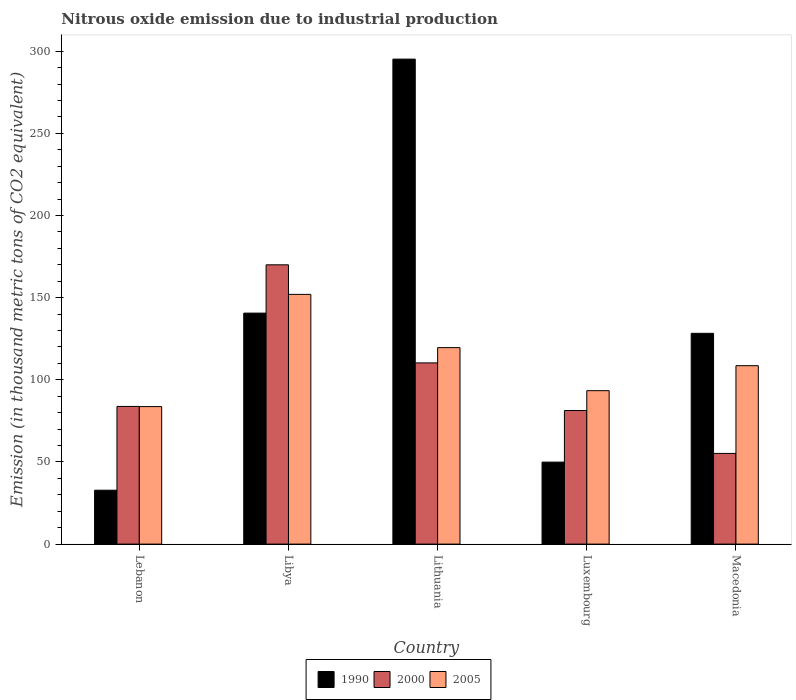How many different coloured bars are there?
Offer a very short reply. 3. Are the number of bars per tick equal to the number of legend labels?
Your answer should be compact. Yes. Are the number of bars on each tick of the X-axis equal?
Give a very brief answer. Yes. How many bars are there on the 4th tick from the left?
Your answer should be very brief. 3. What is the label of the 1st group of bars from the left?
Offer a terse response. Lebanon. In how many cases, is the number of bars for a given country not equal to the number of legend labels?
Make the answer very short. 0. What is the amount of nitrous oxide emitted in 2000 in Lithuania?
Give a very brief answer. 110.3. Across all countries, what is the maximum amount of nitrous oxide emitted in 2000?
Keep it short and to the point. 170. Across all countries, what is the minimum amount of nitrous oxide emitted in 1990?
Offer a terse response. 32.8. In which country was the amount of nitrous oxide emitted in 1990 maximum?
Keep it short and to the point. Lithuania. In which country was the amount of nitrous oxide emitted in 2005 minimum?
Offer a terse response. Lebanon. What is the total amount of nitrous oxide emitted in 2000 in the graph?
Provide a succinct answer. 500.6. What is the difference between the amount of nitrous oxide emitted in 1990 in Lithuania and that in Luxembourg?
Offer a terse response. 245.3. What is the difference between the amount of nitrous oxide emitted in 2000 in Lithuania and the amount of nitrous oxide emitted in 1990 in Luxembourg?
Your answer should be very brief. 60.4. What is the average amount of nitrous oxide emitted in 2000 per country?
Provide a succinct answer. 100.12. What is the difference between the amount of nitrous oxide emitted of/in 1990 and amount of nitrous oxide emitted of/in 2000 in Macedonia?
Your answer should be compact. 73.1. What is the ratio of the amount of nitrous oxide emitted in 2000 in Libya to that in Luxembourg?
Give a very brief answer. 2.09. Is the amount of nitrous oxide emitted in 2000 in Lebanon less than that in Luxembourg?
Provide a short and direct response. No. Is the difference between the amount of nitrous oxide emitted in 1990 in Lebanon and Lithuania greater than the difference between the amount of nitrous oxide emitted in 2000 in Lebanon and Lithuania?
Your answer should be very brief. No. What is the difference between the highest and the second highest amount of nitrous oxide emitted in 1990?
Your response must be concise. -12.3. What is the difference between the highest and the lowest amount of nitrous oxide emitted in 2000?
Your response must be concise. 114.8. In how many countries, is the amount of nitrous oxide emitted in 2000 greater than the average amount of nitrous oxide emitted in 2000 taken over all countries?
Your response must be concise. 2. Is the sum of the amount of nitrous oxide emitted in 1990 in Libya and Macedonia greater than the maximum amount of nitrous oxide emitted in 2000 across all countries?
Your response must be concise. Yes. What does the 2nd bar from the left in Libya represents?
Your response must be concise. 2000. How many bars are there?
Provide a short and direct response. 15. What is the difference between two consecutive major ticks on the Y-axis?
Make the answer very short. 50. Are the values on the major ticks of Y-axis written in scientific E-notation?
Offer a terse response. No. Does the graph contain any zero values?
Your answer should be very brief. No. How many legend labels are there?
Give a very brief answer. 3. What is the title of the graph?
Provide a short and direct response. Nitrous oxide emission due to industrial production. What is the label or title of the Y-axis?
Provide a succinct answer. Emission (in thousand metric tons of CO2 equivalent). What is the Emission (in thousand metric tons of CO2 equivalent) in 1990 in Lebanon?
Your answer should be very brief. 32.8. What is the Emission (in thousand metric tons of CO2 equivalent) of 2000 in Lebanon?
Make the answer very short. 83.8. What is the Emission (in thousand metric tons of CO2 equivalent) in 2005 in Lebanon?
Your answer should be very brief. 83.7. What is the Emission (in thousand metric tons of CO2 equivalent) of 1990 in Libya?
Provide a succinct answer. 140.6. What is the Emission (in thousand metric tons of CO2 equivalent) of 2000 in Libya?
Offer a very short reply. 170. What is the Emission (in thousand metric tons of CO2 equivalent) of 2005 in Libya?
Provide a short and direct response. 152. What is the Emission (in thousand metric tons of CO2 equivalent) in 1990 in Lithuania?
Make the answer very short. 295.2. What is the Emission (in thousand metric tons of CO2 equivalent) of 2000 in Lithuania?
Offer a very short reply. 110.3. What is the Emission (in thousand metric tons of CO2 equivalent) of 2005 in Lithuania?
Provide a succinct answer. 119.6. What is the Emission (in thousand metric tons of CO2 equivalent) in 1990 in Luxembourg?
Offer a terse response. 49.9. What is the Emission (in thousand metric tons of CO2 equivalent) of 2000 in Luxembourg?
Your response must be concise. 81.3. What is the Emission (in thousand metric tons of CO2 equivalent) in 2005 in Luxembourg?
Keep it short and to the point. 93.4. What is the Emission (in thousand metric tons of CO2 equivalent) of 1990 in Macedonia?
Offer a terse response. 128.3. What is the Emission (in thousand metric tons of CO2 equivalent) of 2000 in Macedonia?
Your answer should be compact. 55.2. What is the Emission (in thousand metric tons of CO2 equivalent) in 2005 in Macedonia?
Provide a short and direct response. 108.6. Across all countries, what is the maximum Emission (in thousand metric tons of CO2 equivalent) in 1990?
Provide a short and direct response. 295.2. Across all countries, what is the maximum Emission (in thousand metric tons of CO2 equivalent) of 2000?
Offer a very short reply. 170. Across all countries, what is the maximum Emission (in thousand metric tons of CO2 equivalent) of 2005?
Keep it short and to the point. 152. Across all countries, what is the minimum Emission (in thousand metric tons of CO2 equivalent) of 1990?
Offer a very short reply. 32.8. Across all countries, what is the minimum Emission (in thousand metric tons of CO2 equivalent) of 2000?
Offer a very short reply. 55.2. Across all countries, what is the minimum Emission (in thousand metric tons of CO2 equivalent) in 2005?
Offer a very short reply. 83.7. What is the total Emission (in thousand metric tons of CO2 equivalent) in 1990 in the graph?
Ensure brevity in your answer.  646.8. What is the total Emission (in thousand metric tons of CO2 equivalent) in 2000 in the graph?
Provide a short and direct response. 500.6. What is the total Emission (in thousand metric tons of CO2 equivalent) in 2005 in the graph?
Your answer should be very brief. 557.3. What is the difference between the Emission (in thousand metric tons of CO2 equivalent) in 1990 in Lebanon and that in Libya?
Your response must be concise. -107.8. What is the difference between the Emission (in thousand metric tons of CO2 equivalent) in 2000 in Lebanon and that in Libya?
Offer a very short reply. -86.2. What is the difference between the Emission (in thousand metric tons of CO2 equivalent) of 2005 in Lebanon and that in Libya?
Provide a short and direct response. -68.3. What is the difference between the Emission (in thousand metric tons of CO2 equivalent) in 1990 in Lebanon and that in Lithuania?
Give a very brief answer. -262.4. What is the difference between the Emission (in thousand metric tons of CO2 equivalent) in 2000 in Lebanon and that in Lithuania?
Provide a succinct answer. -26.5. What is the difference between the Emission (in thousand metric tons of CO2 equivalent) in 2005 in Lebanon and that in Lithuania?
Ensure brevity in your answer.  -35.9. What is the difference between the Emission (in thousand metric tons of CO2 equivalent) of 1990 in Lebanon and that in Luxembourg?
Your answer should be compact. -17.1. What is the difference between the Emission (in thousand metric tons of CO2 equivalent) of 2000 in Lebanon and that in Luxembourg?
Ensure brevity in your answer.  2.5. What is the difference between the Emission (in thousand metric tons of CO2 equivalent) of 2005 in Lebanon and that in Luxembourg?
Your response must be concise. -9.7. What is the difference between the Emission (in thousand metric tons of CO2 equivalent) of 1990 in Lebanon and that in Macedonia?
Keep it short and to the point. -95.5. What is the difference between the Emission (in thousand metric tons of CO2 equivalent) in 2000 in Lebanon and that in Macedonia?
Give a very brief answer. 28.6. What is the difference between the Emission (in thousand metric tons of CO2 equivalent) of 2005 in Lebanon and that in Macedonia?
Offer a terse response. -24.9. What is the difference between the Emission (in thousand metric tons of CO2 equivalent) in 1990 in Libya and that in Lithuania?
Offer a terse response. -154.6. What is the difference between the Emission (in thousand metric tons of CO2 equivalent) in 2000 in Libya and that in Lithuania?
Offer a very short reply. 59.7. What is the difference between the Emission (in thousand metric tons of CO2 equivalent) of 2005 in Libya and that in Lithuania?
Offer a terse response. 32.4. What is the difference between the Emission (in thousand metric tons of CO2 equivalent) of 1990 in Libya and that in Luxembourg?
Your answer should be very brief. 90.7. What is the difference between the Emission (in thousand metric tons of CO2 equivalent) in 2000 in Libya and that in Luxembourg?
Give a very brief answer. 88.7. What is the difference between the Emission (in thousand metric tons of CO2 equivalent) of 2005 in Libya and that in Luxembourg?
Your answer should be compact. 58.6. What is the difference between the Emission (in thousand metric tons of CO2 equivalent) of 1990 in Libya and that in Macedonia?
Offer a terse response. 12.3. What is the difference between the Emission (in thousand metric tons of CO2 equivalent) of 2000 in Libya and that in Macedonia?
Offer a terse response. 114.8. What is the difference between the Emission (in thousand metric tons of CO2 equivalent) of 2005 in Libya and that in Macedonia?
Your answer should be compact. 43.4. What is the difference between the Emission (in thousand metric tons of CO2 equivalent) of 1990 in Lithuania and that in Luxembourg?
Make the answer very short. 245.3. What is the difference between the Emission (in thousand metric tons of CO2 equivalent) of 2005 in Lithuania and that in Luxembourg?
Make the answer very short. 26.2. What is the difference between the Emission (in thousand metric tons of CO2 equivalent) of 1990 in Lithuania and that in Macedonia?
Give a very brief answer. 166.9. What is the difference between the Emission (in thousand metric tons of CO2 equivalent) of 2000 in Lithuania and that in Macedonia?
Ensure brevity in your answer.  55.1. What is the difference between the Emission (in thousand metric tons of CO2 equivalent) of 1990 in Luxembourg and that in Macedonia?
Your response must be concise. -78.4. What is the difference between the Emission (in thousand metric tons of CO2 equivalent) of 2000 in Luxembourg and that in Macedonia?
Your answer should be compact. 26.1. What is the difference between the Emission (in thousand metric tons of CO2 equivalent) in 2005 in Luxembourg and that in Macedonia?
Give a very brief answer. -15.2. What is the difference between the Emission (in thousand metric tons of CO2 equivalent) in 1990 in Lebanon and the Emission (in thousand metric tons of CO2 equivalent) in 2000 in Libya?
Provide a short and direct response. -137.2. What is the difference between the Emission (in thousand metric tons of CO2 equivalent) of 1990 in Lebanon and the Emission (in thousand metric tons of CO2 equivalent) of 2005 in Libya?
Provide a succinct answer. -119.2. What is the difference between the Emission (in thousand metric tons of CO2 equivalent) in 2000 in Lebanon and the Emission (in thousand metric tons of CO2 equivalent) in 2005 in Libya?
Keep it short and to the point. -68.2. What is the difference between the Emission (in thousand metric tons of CO2 equivalent) in 1990 in Lebanon and the Emission (in thousand metric tons of CO2 equivalent) in 2000 in Lithuania?
Your answer should be very brief. -77.5. What is the difference between the Emission (in thousand metric tons of CO2 equivalent) of 1990 in Lebanon and the Emission (in thousand metric tons of CO2 equivalent) of 2005 in Lithuania?
Ensure brevity in your answer.  -86.8. What is the difference between the Emission (in thousand metric tons of CO2 equivalent) of 2000 in Lebanon and the Emission (in thousand metric tons of CO2 equivalent) of 2005 in Lithuania?
Make the answer very short. -35.8. What is the difference between the Emission (in thousand metric tons of CO2 equivalent) of 1990 in Lebanon and the Emission (in thousand metric tons of CO2 equivalent) of 2000 in Luxembourg?
Your response must be concise. -48.5. What is the difference between the Emission (in thousand metric tons of CO2 equivalent) in 1990 in Lebanon and the Emission (in thousand metric tons of CO2 equivalent) in 2005 in Luxembourg?
Make the answer very short. -60.6. What is the difference between the Emission (in thousand metric tons of CO2 equivalent) in 2000 in Lebanon and the Emission (in thousand metric tons of CO2 equivalent) in 2005 in Luxembourg?
Your answer should be compact. -9.6. What is the difference between the Emission (in thousand metric tons of CO2 equivalent) of 1990 in Lebanon and the Emission (in thousand metric tons of CO2 equivalent) of 2000 in Macedonia?
Your answer should be very brief. -22.4. What is the difference between the Emission (in thousand metric tons of CO2 equivalent) of 1990 in Lebanon and the Emission (in thousand metric tons of CO2 equivalent) of 2005 in Macedonia?
Make the answer very short. -75.8. What is the difference between the Emission (in thousand metric tons of CO2 equivalent) in 2000 in Lebanon and the Emission (in thousand metric tons of CO2 equivalent) in 2005 in Macedonia?
Provide a short and direct response. -24.8. What is the difference between the Emission (in thousand metric tons of CO2 equivalent) of 1990 in Libya and the Emission (in thousand metric tons of CO2 equivalent) of 2000 in Lithuania?
Your answer should be compact. 30.3. What is the difference between the Emission (in thousand metric tons of CO2 equivalent) of 1990 in Libya and the Emission (in thousand metric tons of CO2 equivalent) of 2005 in Lithuania?
Provide a succinct answer. 21. What is the difference between the Emission (in thousand metric tons of CO2 equivalent) of 2000 in Libya and the Emission (in thousand metric tons of CO2 equivalent) of 2005 in Lithuania?
Keep it short and to the point. 50.4. What is the difference between the Emission (in thousand metric tons of CO2 equivalent) of 1990 in Libya and the Emission (in thousand metric tons of CO2 equivalent) of 2000 in Luxembourg?
Your answer should be compact. 59.3. What is the difference between the Emission (in thousand metric tons of CO2 equivalent) of 1990 in Libya and the Emission (in thousand metric tons of CO2 equivalent) of 2005 in Luxembourg?
Provide a short and direct response. 47.2. What is the difference between the Emission (in thousand metric tons of CO2 equivalent) of 2000 in Libya and the Emission (in thousand metric tons of CO2 equivalent) of 2005 in Luxembourg?
Your answer should be very brief. 76.6. What is the difference between the Emission (in thousand metric tons of CO2 equivalent) in 1990 in Libya and the Emission (in thousand metric tons of CO2 equivalent) in 2000 in Macedonia?
Give a very brief answer. 85.4. What is the difference between the Emission (in thousand metric tons of CO2 equivalent) of 2000 in Libya and the Emission (in thousand metric tons of CO2 equivalent) of 2005 in Macedonia?
Give a very brief answer. 61.4. What is the difference between the Emission (in thousand metric tons of CO2 equivalent) in 1990 in Lithuania and the Emission (in thousand metric tons of CO2 equivalent) in 2000 in Luxembourg?
Offer a terse response. 213.9. What is the difference between the Emission (in thousand metric tons of CO2 equivalent) of 1990 in Lithuania and the Emission (in thousand metric tons of CO2 equivalent) of 2005 in Luxembourg?
Your answer should be compact. 201.8. What is the difference between the Emission (in thousand metric tons of CO2 equivalent) in 2000 in Lithuania and the Emission (in thousand metric tons of CO2 equivalent) in 2005 in Luxembourg?
Keep it short and to the point. 16.9. What is the difference between the Emission (in thousand metric tons of CO2 equivalent) in 1990 in Lithuania and the Emission (in thousand metric tons of CO2 equivalent) in 2000 in Macedonia?
Provide a short and direct response. 240. What is the difference between the Emission (in thousand metric tons of CO2 equivalent) in 1990 in Lithuania and the Emission (in thousand metric tons of CO2 equivalent) in 2005 in Macedonia?
Your response must be concise. 186.6. What is the difference between the Emission (in thousand metric tons of CO2 equivalent) in 2000 in Lithuania and the Emission (in thousand metric tons of CO2 equivalent) in 2005 in Macedonia?
Keep it short and to the point. 1.7. What is the difference between the Emission (in thousand metric tons of CO2 equivalent) of 1990 in Luxembourg and the Emission (in thousand metric tons of CO2 equivalent) of 2000 in Macedonia?
Ensure brevity in your answer.  -5.3. What is the difference between the Emission (in thousand metric tons of CO2 equivalent) in 1990 in Luxembourg and the Emission (in thousand metric tons of CO2 equivalent) in 2005 in Macedonia?
Provide a succinct answer. -58.7. What is the difference between the Emission (in thousand metric tons of CO2 equivalent) of 2000 in Luxembourg and the Emission (in thousand metric tons of CO2 equivalent) of 2005 in Macedonia?
Make the answer very short. -27.3. What is the average Emission (in thousand metric tons of CO2 equivalent) of 1990 per country?
Provide a succinct answer. 129.36. What is the average Emission (in thousand metric tons of CO2 equivalent) in 2000 per country?
Offer a terse response. 100.12. What is the average Emission (in thousand metric tons of CO2 equivalent) in 2005 per country?
Provide a short and direct response. 111.46. What is the difference between the Emission (in thousand metric tons of CO2 equivalent) of 1990 and Emission (in thousand metric tons of CO2 equivalent) of 2000 in Lebanon?
Your response must be concise. -51. What is the difference between the Emission (in thousand metric tons of CO2 equivalent) in 1990 and Emission (in thousand metric tons of CO2 equivalent) in 2005 in Lebanon?
Your answer should be compact. -50.9. What is the difference between the Emission (in thousand metric tons of CO2 equivalent) in 1990 and Emission (in thousand metric tons of CO2 equivalent) in 2000 in Libya?
Your answer should be very brief. -29.4. What is the difference between the Emission (in thousand metric tons of CO2 equivalent) of 2000 and Emission (in thousand metric tons of CO2 equivalent) of 2005 in Libya?
Your response must be concise. 18. What is the difference between the Emission (in thousand metric tons of CO2 equivalent) of 1990 and Emission (in thousand metric tons of CO2 equivalent) of 2000 in Lithuania?
Ensure brevity in your answer.  184.9. What is the difference between the Emission (in thousand metric tons of CO2 equivalent) in 1990 and Emission (in thousand metric tons of CO2 equivalent) in 2005 in Lithuania?
Provide a succinct answer. 175.6. What is the difference between the Emission (in thousand metric tons of CO2 equivalent) in 2000 and Emission (in thousand metric tons of CO2 equivalent) in 2005 in Lithuania?
Your answer should be very brief. -9.3. What is the difference between the Emission (in thousand metric tons of CO2 equivalent) in 1990 and Emission (in thousand metric tons of CO2 equivalent) in 2000 in Luxembourg?
Make the answer very short. -31.4. What is the difference between the Emission (in thousand metric tons of CO2 equivalent) of 1990 and Emission (in thousand metric tons of CO2 equivalent) of 2005 in Luxembourg?
Ensure brevity in your answer.  -43.5. What is the difference between the Emission (in thousand metric tons of CO2 equivalent) of 2000 and Emission (in thousand metric tons of CO2 equivalent) of 2005 in Luxembourg?
Give a very brief answer. -12.1. What is the difference between the Emission (in thousand metric tons of CO2 equivalent) of 1990 and Emission (in thousand metric tons of CO2 equivalent) of 2000 in Macedonia?
Ensure brevity in your answer.  73.1. What is the difference between the Emission (in thousand metric tons of CO2 equivalent) of 1990 and Emission (in thousand metric tons of CO2 equivalent) of 2005 in Macedonia?
Your answer should be very brief. 19.7. What is the difference between the Emission (in thousand metric tons of CO2 equivalent) in 2000 and Emission (in thousand metric tons of CO2 equivalent) in 2005 in Macedonia?
Ensure brevity in your answer.  -53.4. What is the ratio of the Emission (in thousand metric tons of CO2 equivalent) in 1990 in Lebanon to that in Libya?
Keep it short and to the point. 0.23. What is the ratio of the Emission (in thousand metric tons of CO2 equivalent) in 2000 in Lebanon to that in Libya?
Give a very brief answer. 0.49. What is the ratio of the Emission (in thousand metric tons of CO2 equivalent) in 2005 in Lebanon to that in Libya?
Your answer should be compact. 0.55. What is the ratio of the Emission (in thousand metric tons of CO2 equivalent) of 2000 in Lebanon to that in Lithuania?
Provide a short and direct response. 0.76. What is the ratio of the Emission (in thousand metric tons of CO2 equivalent) in 2005 in Lebanon to that in Lithuania?
Your response must be concise. 0.7. What is the ratio of the Emission (in thousand metric tons of CO2 equivalent) of 1990 in Lebanon to that in Luxembourg?
Your response must be concise. 0.66. What is the ratio of the Emission (in thousand metric tons of CO2 equivalent) of 2000 in Lebanon to that in Luxembourg?
Offer a very short reply. 1.03. What is the ratio of the Emission (in thousand metric tons of CO2 equivalent) in 2005 in Lebanon to that in Luxembourg?
Your answer should be very brief. 0.9. What is the ratio of the Emission (in thousand metric tons of CO2 equivalent) of 1990 in Lebanon to that in Macedonia?
Provide a short and direct response. 0.26. What is the ratio of the Emission (in thousand metric tons of CO2 equivalent) of 2000 in Lebanon to that in Macedonia?
Offer a terse response. 1.52. What is the ratio of the Emission (in thousand metric tons of CO2 equivalent) in 2005 in Lebanon to that in Macedonia?
Offer a terse response. 0.77. What is the ratio of the Emission (in thousand metric tons of CO2 equivalent) of 1990 in Libya to that in Lithuania?
Provide a succinct answer. 0.48. What is the ratio of the Emission (in thousand metric tons of CO2 equivalent) of 2000 in Libya to that in Lithuania?
Keep it short and to the point. 1.54. What is the ratio of the Emission (in thousand metric tons of CO2 equivalent) of 2005 in Libya to that in Lithuania?
Your answer should be compact. 1.27. What is the ratio of the Emission (in thousand metric tons of CO2 equivalent) in 1990 in Libya to that in Luxembourg?
Offer a terse response. 2.82. What is the ratio of the Emission (in thousand metric tons of CO2 equivalent) of 2000 in Libya to that in Luxembourg?
Your response must be concise. 2.09. What is the ratio of the Emission (in thousand metric tons of CO2 equivalent) of 2005 in Libya to that in Luxembourg?
Ensure brevity in your answer.  1.63. What is the ratio of the Emission (in thousand metric tons of CO2 equivalent) of 1990 in Libya to that in Macedonia?
Offer a terse response. 1.1. What is the ratio of the Emission (in thousand metric tons of CO2 equivalent) in 2000 in Libya to that in Macedonia?
Provide a short and direct response. 3.08. What is the ratio of the Emission (in thousand metric tons of CO2 equivalent) in 2005 in Libya to that in Macedonia?
Ensure brevity in your answer.  1.4. What is the ratio of the Emission (in thousand metric tons of CO2 equivalent) of 1990 in Lithuania to that in Luxembourg?
Provide a short and direct response. 5.92. What is the ratio of the Emission (in thousand metric tons of CO2 equivalent) in 2000 in Lithuania to that in Luxembourg?
Offer a terse response. 1.36. What is the ratio of the Emission (in thousand metric tons of CO2 equivalent) in 2005 in Lithuania to that in Luxembourg?
Your response must be concise. 1.28. What is the ratio of the Emission (in thousand metric tons of CO2 equivalent) in 1990 in Lithuania to that in Macedonia?
Your answer should be very brief. 2.3. What is the ratio of the Emission (in thousand metric tons of CO2 equivalent) in 2000 in Lithuania to that in Macedonia?
Provide a short and direct response. 2. What is the ratio of the Emission (in thousand metric tons of CO2 equivalent) in 2005 in Lithuania to that in Macedonia?
Give a very brief answer. 1.1. What is the ratio of the Emission (in thousand metric tons of CO2 equivalent) of 1990 in Luxembourg to that in Macedonia?
Your answer should be very brief. 0.39. What is the ratio of the Emission (in thousand metric tons of CO2 equivalent) in 2000 in Luxembourg to that in Macedonia?
Your response must be concise. 1.47. What is the ratio of the Emission (in thousand metric tons of CO2 equivalent) in 2005 in Luxembourg to that in Macedonia?
Keep it short and to the point. 0.86. What is the difference between the highest and the second highest Emission (in thousand metric tons of CO2 equivalent) in 1990?
Provide a short and direct response. 154.6. What is the difference between the highest and the second highest Emission (in thousand metric tons of CO2 equivalent) in 2000?
Your answer should be very brief. 59.7. What is the difference between the highest and the second highest Emission (in thousand metric tons of CO2 equivalent) in 2005?
Provide a short and direct response. 32.4. What is the difference between the highest and the lowest Emission (in thousand metric tons of CO2 equivalent) in 1990?
Offer a terse response. 262.4. What is the difference between the highest and the lowest Emission (in thousand metric tons of CO2 equivalent) in 2000?
Your response must be concise. 114.8. What is the difference between the highest and the lowest Emission (in thousand metric tons of CO2 equivalent) of 2005?
Ensure brevity in your answer.  68.3. 